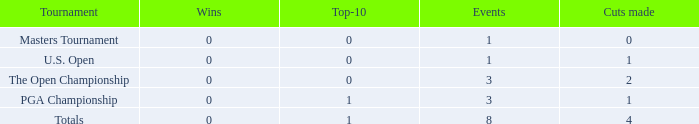Parse the table in full. {'header': ['Tournament', 'Wins', 'Top-10', 'Events', 'Cuts made'], 'rows': [['Masters Tournament', '0', '0', '1', '0'], ['U.S. Open', '0', '0', '1', '1'], ['The Open Championship', '0', '0', '3', '2'], ['PGA Championship', '0', '1', '3', '1'], ['Totals', '0', '1', '8', '4']]} For majors with 8 events played and more than 1 made cut, what is the most top-10s recorded? 1.0. 